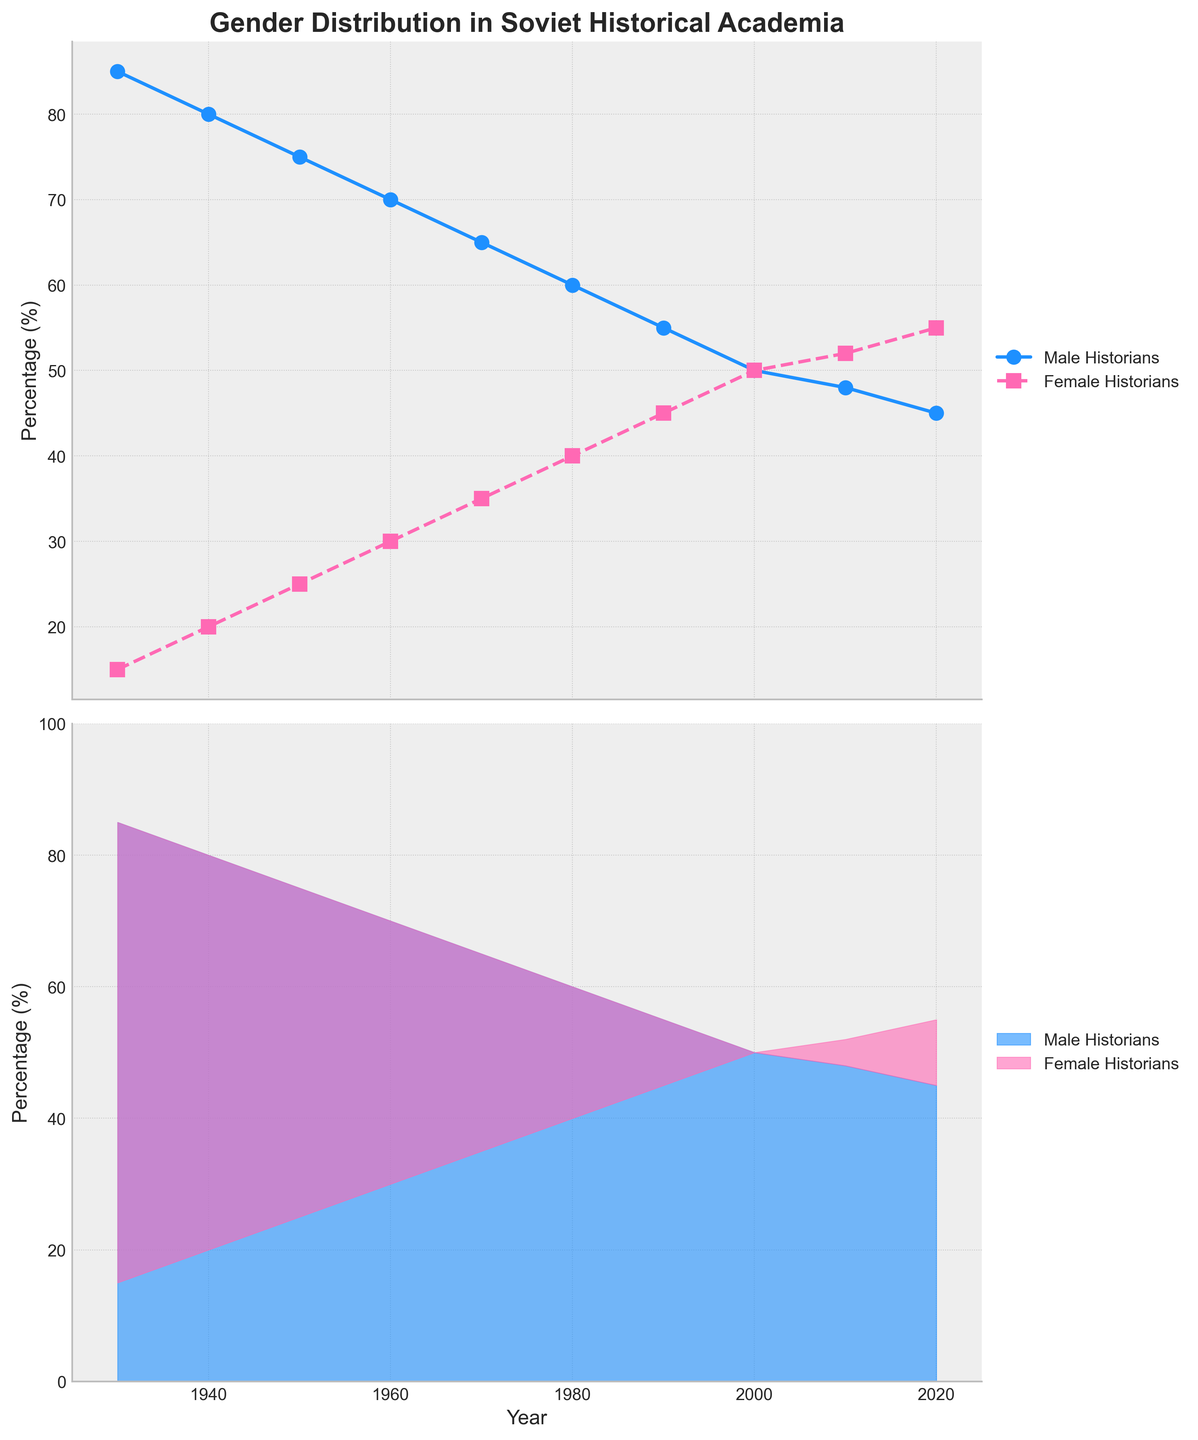How many years are depicted in the figure? The figure covers the range from 1930 to 2020, inclusive. To find the number of years, count the intervals including both end years.
Answer: 10 years Which gender saw an increase in percentage from 1930 to 2020? Looking at the trend of the lines, the percentage of female historians increased, while that of male historians decreased.
Answer: Female historians In what year did the percentage of male historians first drop below 60%? The percentage of male historians first dropped below 60% in 1980, as seen in the line plot.
Answer: 1980 Based on the area plot, estimate the combined percentage of male and female historians in 1940. In the area plot, the two areas add up to 100% for every year. Thus, for 1940, the combined percentage of male and female historians is 100%.
Answer: 100% What was the percentage difference between male and female historians in 1950? In 1950, the percentage of male historians was 75%, and the percentage of female historians was 25%. The difference is 75% - 25%.
Answer: 50 percentage points In which decade did the percentage of female historians surpass that of male historians? By observing the intersection of the lines in the line plot, the percentage of female historians surpassed that of male historians in the 2000s.
Answer: 2000s How did the percentage of female historians change from 1980 to 2000? In 1980, there were 40% female historians, and by 2000, there were 50%. Subtracting these gives 50% - 40%.
Answer: Increased by 10 percentage points Which gender had the highest percentage in 1970? By looking at the line plot or the area plot, it is evident that male historians had the highest percentage in 1970.
Answer: Male historians What is the percentage change in male historians from 1930 to 2020? The percentage declined from 85% in 1930 to 45% in 2020. The change is 85% - 45%.
Answer: Decreased by 40 percentage points Between which consecutive decades was the percentage gain for female historians the largest? By comparing the line segments on the line plot, the largest gain for female historians was between 1950 and 1960, increasing from 25% to 30%.
Answer: 1950 to 1960 